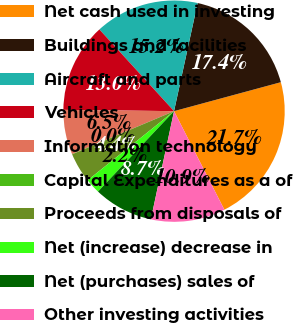Convert chart. <chart><loc_0><loc_0><loc_500><loc_500><pie_chart><fcel>Net cash used in investing<fcel>Buildings and facilities<fcel>Aircraft and parts<fcel>Vehicles<fcel>Information technology<fcel>Capital Expenditures as a of<fcel>Proceeds from disposals of<fcel>Net (increase) decrease in<fcel>Net (purchases) sales of<fcel>Other investing activities<nl><fcel>21.7%<fcel>17.37%<fcel>15.2%<fcel>13.03%<fcel>6.53%<fcel>0.03%<fcel>4.37%<fcel>2.2%<fcel>8.7%<fcel>10.87%<nl></chart> 